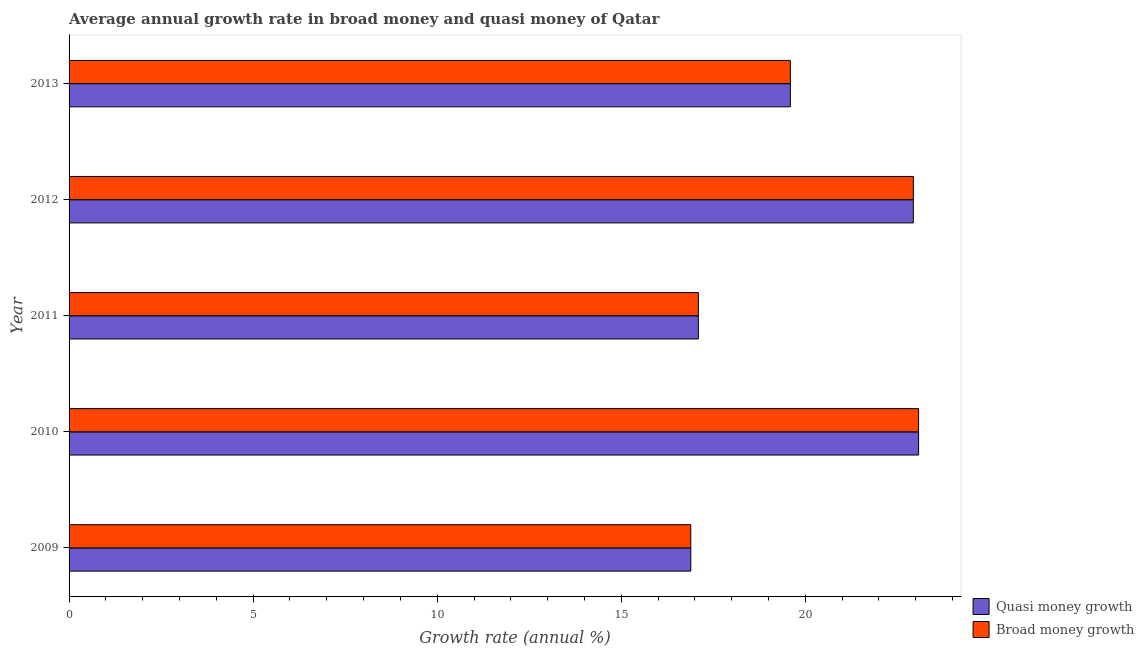Are the number of bars on each tick of the Y-axis equal?
Provide a succinct answer. Yes. What is the label of the 3rd group of bars from the top?
Offer a terse response. 2011. In how many cases, is the number of bars for a given year not equal to the number of legend labels?
Make the answer very short. 0. What is the annual growth rate in quasi money in 2010?
Offer a terse response. 23.08. Across all years, what is the maximum annual growth rate in quasi money?
Ensure brevity in your answer.  23.08. Across all years, what is the minimum annual growth rate in quasi money?
Offer a terse response. 16.89. What is the total annual growth rate in broad money in the graph?
Your answer should be very brief. 99.59. What is the difference between the annual growth rate in quasi money in 2010 and that in 2012?
Your answer should be very brief. 0.14. What is the difference between the annual growth rate in quasi money in 2012 and the annual growth rate in broad money in 2009?
Provide a short and direct response. 6.04. What is the average annual growth rate in broad money per year?
Your response must be concise. 19.92. What is the ratio of the annual growth rate in broad money in 2009 to that in 2010?
Ensure brevity in your answer.  0.73. Is the annual growth rate in quasi money in 2009 less than that in 2011?
Offer a terse response. Yes. Is the difference between the annual growth rate in broad money in 2009 and 2011 greater than the difference between the annual growth rate in quasi money in 2009 and 2011?
Make the answer very short. No. What is the difference between the highest and the second highest annual growth rate in broad money?
Give a very brief answer. 0.14. What is the difference between the highest and the lowest annual growth rate in quasi money?
Keep it short and to the point. 6.19. Is the sum of the annual growth rate in broad money in 2009 and 2011 greater than the maximum annual growth rate in quasi money across all years?
Your answer should be very brief. Yes. What does the 2nd bar from the top in 2011 represents?
Provide a short and direct response. Quasi money growth. What does the 2nd bar from the bottom in 2009 represents?
Provide a short and direct response. Broad money growth. How many bars are there?
Offer a terse response. 10. Are all the bars in the graph horizontal?
Your answer should be very brief. Yes. How many years are there in the graph?
Provide a short and direct response. 5. Are the values on the major ticks of X-axis written in scientific E-notation?
Ensure brevity in your answer.  No. How are the legend labels stacked?
Provide a succinct answer. Vertical. What is the title of the graph?
Your answer should be compact. Average annual growth rate in broad money and quasi money of Qatar. Does "Age 65(female)" appear as one of the legend labels in the graph?
Offer a very short reply. No. What is the label or title of the X-axis?
Make the answer very short. Growth rate (annual %). What is the Growth rate (annual %) in Quasi money growth in 2009?
Provide a short and direct response. 16.89. What is the Growth rate (annual %) of Broad money growth in 2009?
Offer a terse response. 16.89. What is the Growth rate (annual %) of Quasi money growth in 2010?
Offer a very short reply. 23.08. What is the Growth rate (annual %) in Broad money growth in 2010?
Ensure brevity in your answer.  23.08. What is the Growth rate (annual %) of Quasi money growth in 2011?
Your response must be concise. 17.09. What is the Growth rate (annual %) in Broad money growth in 2011?
Give a very brief answer. 17.09. What is the Growth rate (annual %) of Quasi money growth in 2012?
Keep it short and to the point. 22.93. What is the Growth rate (annual %) of Broad money growth in 2012?
Offer a very short reply. 22.93. What is the Growth rate (annual %) in Quasi money growth in 2013?
Offer a terse response. 19.59. What is the Growth rate (annual %) of Broad money growth in 2013?
Your answer should be compact. 19.59. Across all years, what is the maximum Growth rate (annual %) in Quasi money growth?
Make the answer very short. 23.08. Across all years, what is the maximum Growth rate (annual %) of Broad money growth?
Make the answer very short. 23.08. Across all years, what is the minimum Growth rate (annual %) in Quasi money growth?
Ensure brevity in your answer.  16.89. Across all years, what is the minimum Growth rate (annual %) in Broad money growth?
Offer a very short reply. 16.89. What is the total Growth rate (annual %) in Quasi money growth in the graph?
Keep it short and to the point. 99.59. What is the total Growth rate (annual %) of Broad money growth in the graph?
Make the answer very short. 99.59. What is the difference between the Growth rate (annual %) in Quasi money growth in 2009 and that in 2010?
Your answer should be very brief. -6.19. What is the difference between the Growth rate (annual %) in Broad money growth in 2009 and that in 2010?
Ensure brevity in your answer.  -6.19. What is the difference between the Growth rate (annual %) in Quasi money growth in 2009 and that in 2011?
Give a very brief answer. -0.2. What is the difference between the Growth rate (annual %) of Broad money growth in 2009 and that in 2011?
Give a very brief answer. -0.2. What is the difference between the Growth rate (annual %) in Quasi money growth in 2009 and that in 2012?
Your answer should be compact. -6.04. What is the difference between the Growth rate (annual %) of Broad money growth in 2009 and that in 2012?
Provide a succinct answer. -6.04. What is the difference between the Growth rate (annual %) of Quasi money growth in 2009 and that in 2013?
Offer a terse response. -2.7. What is the difference between the Growth rate (annual %) of Broad money growth in 2009 and that in 2013?
Your answer should be very brief. -2.7. What is the difference between the Growth rate (annual %) of Quasi money growth in 2010 and that in 2011?
Ensure brevity in your answer.  5.98. What is the difference between the Growth rate (annual %) in Broad money growth in 2010 and that in 2011?
Ensure brevity in your answer.  5.98. What is the difference between the Growth rate (annual %) of Quasi money growth in 2010 and that in 2012?
Your response must be concise. 0.14. What is the difference between the Growth rate (annual %) of Broad money growth in 2010 and that in 2012?
Provide a short and direct response. 0.14. What is the difference between the Growth rate (annual %) in Quasi money growth in 2010 and that in 2013?
Provide a succinct answer. 3.48. What is the difference between the Growth rate (annual %) in Broad money growth in 2010 and that in 2013?
Give a very brief answer. 3.48. What is the difference between the Growth rate (annual %) of Quasi money growth in 2011 and that in 2012?
Your answer should be compact. -5.84. What is the difference between the Growth rate (annual %) in Broad money growth in 2011 and that in 2012?
Provide a short and direct response. -5.84. What is the difference between the Growth rate (annual %) of Quasi money growth in 2011 and that in 2013?
Ensure brevity in your answer.  -2.5. What is the difference between the Growth rate (annual %) in Broad money growth in 2011 and that in 2013?
Make the answer very short. -2.5. What is the difference between the Growth rate (annual %) in Quasi money growth in 2012 and that in 2013?
Your answer should be compact. 3.34. What is the difference between the Growth rate (annual %) in Broad money growth in 2012 and that in 2013?
Keep it short and to the point. 3.34. What is the difference between the Growth rate (annual %) of Quasi money growth in 2009 and the Growth rate (annual %) of Broad money growth in 2010?
Give a very brief answer. -6.19. What is the difference between the Growth rate (annual %) in Quasi money growth in 2009 and the Growth rate (annual %) in Broad money growth in 2011?
Your answer should be very brief. -0.2. What is the difference between the Growth rate (annual %) of Quasi money growth in 2009 and the Growth rate (annual %) of Broad money growth in 2012?
Provide a succinct answer. -6.04. What is the difference between the Growth rate (annual %) of Quasi money growth in 2009 and the Growth rate (annual %) of Broad money growth in 2013?
Your answer should be very brief. -2.7. What is the difference between the Growth rate (annual %) in Quasi money growth in 2010 and the Growth rate (annual %) in Broad money growth in 2011?
Make the answer very short. 5.98. What is the difference between the Growth rate (annual %) of Quasi money growth in 2010 and the Growth rate (annual %) of Broad money growth in 2012?
Provide a succinct answer. 0.14. What is the difference between the Growth rate (annual %) in Quasi money growth in 2010 and the Growth rate (annual %) in Broad money growth in 2013?
Provide a short and direct response. 3.48. What is the difference between the Growth rate (annual %) of Quasi money growth in 2011 and the Growth rate (annual %) of Broad money growth in 2012?
Offer a very short reply. -5.84. What is the difference between the Growth rate (annual %) in Quasi money growth in 2011 and the Growth rate (annual %) in Broad money growth in 2013?
Your response must be concise. -2.5. What is the difference between the Growth rate (annual %) of Quasi money growth in 2012 and the Growth rate (annual %) of Broad money growth in 2013?
Your response must be concise. 3.34. What is the average Growth rate (annual %) of Quasi money growth per year?
Provide a short and direct response. 19.92. What is the average Growth rate (annual %) in Broad money growth per year?
Ensure brevity in your answer.  19.92. In the year 2013, what is the difference between the Growth rate (annual %) in Quasi money growth and Growth rate (annual %) in Broad money growth?
Your response must be concise. 0. What is the ratio of the Growth rate (annual %) of Quasi money growth in 2009 to that in 2010?
Provide a succinct answer. 0.73. What is the ratio of the Growth rate (annual %) in Broad money growth in 2009 to that in 2010?
Offer a very short reply. 0.73. What is the ratio of the Growth rate (annual %) of Quasi money growth in 2009 to that in 2011?
Give a very brief answer. 0.99. What is the ratio of the Growth rate (annual %) in Quasi money growth in 2009 to that in 2012?
Ensure brevity in your answer.  0.74. What is the ratio of the Growth rate (annual %) of Broad money growth in 2009 to that in 2012?
Provide a succinct answer. 0.74. What is the ratio of the Growth rate (annual %) of Quasi money growth in 2009 to that in 2013?
Offer a very short reply. 0.86. What is the ratio of the Growth rate (annual %) in Broad money growth in 2009 to that in 2013?
Provide a short and direct response. 0.86. What is the ratio of the Growth rate (annual %) of Quasi money growth in 2010 to that in 2011?
Offer a very short reply. 1.35. What is the ratio of the Growth rate (annual %) in Broad money growth in 2010 to that in 2011?
Keep it short and to the point. 1.35. What is the ratio of the Growth rate (annual %) of Quasi money growth in 2010 to that in 2012?
Provide a succinct answer. 1.01. What is the ratio of the Growth rate (annual %) in Quasi money growth in 2010 to that in 2013?
Provide a succinct answer. 1.18. What is the ratio of the Growth rate (annual %) of Broad money growth in 2010 to that in 2013?
Keep it short and to the point. 1.18. What is the ratio of the Growth rate (annual %) in Quasi money growth in 2011 to that in 2012?
Give a very brief answer. 0.75. What is the ratio of the Growth rate (annual %) of Broad money growth in 2011 to that in 2012?
Provide a succinct answer. 0.75. What is the ratio of the Growth rate (annual %) of Quasi money growth in 2011 to that in 2013?
Make the answer very short. 0.87. What is the ratio of the Growth rate (annual %) in Broad money growth in 2011 to that in 2013?
Keep it short and to the point. 0.87. What is the ratio of the Growth rate (annual %) of Quasi money growth in 2012 to that in 2013?
Ensure brevity in your answer.  1.17. What is the ratio of the Growth rate (annual %) in Broad money growth in 2012 to that in 2013?
Your answer should be compact. 1.17. What is the difference between the highest and the second highest Growth rate (annual %) of Quasi money growth?
Keep it short and to the point. 0.14. What is the difference between the highest and the second highest Growth rate (annual %) of Broad money growth?
Your response must be concise. 0.14. What is the difference between the highest and the lowest Growth rate (annual %) in Quasi money growth?
Provide a succinct answer. 6.19. What is the difference between the highest and the lowest Growth rate (annual %) in Broad money growth?
Your answer should be very brief. 6.19. 